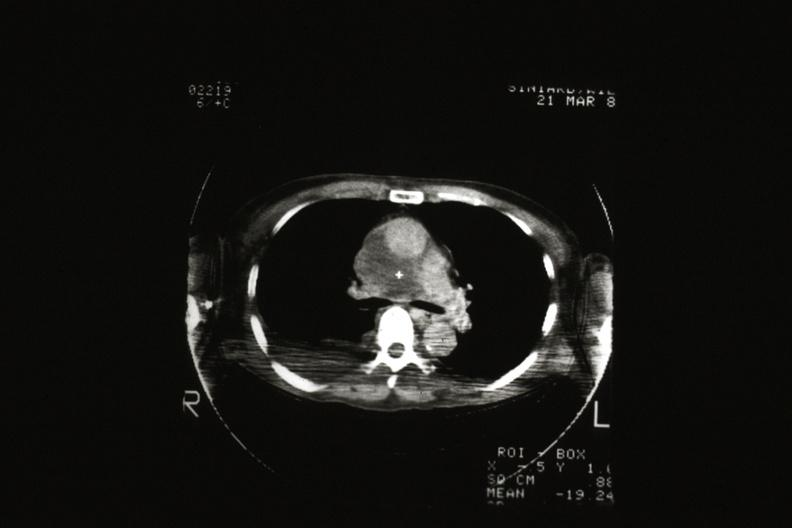what is present?
Answer the question using a single word or phrase. Hematologic 